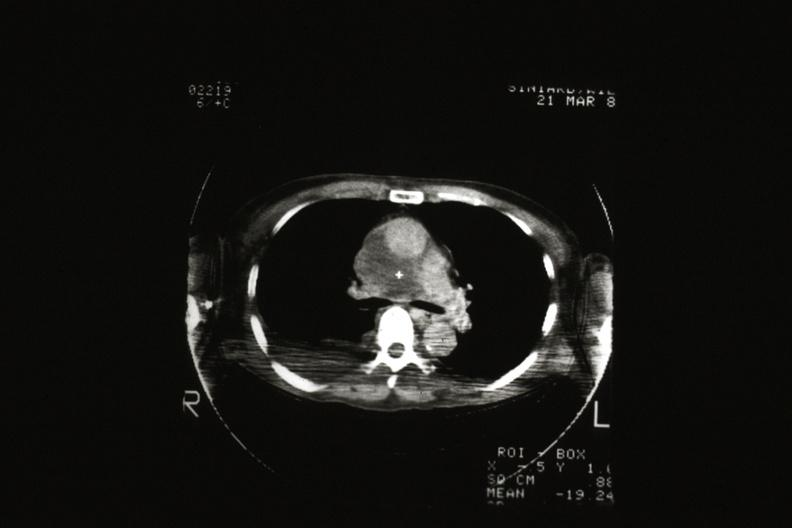what is present?
Answer the question using a single word or phrase. Hematologic 